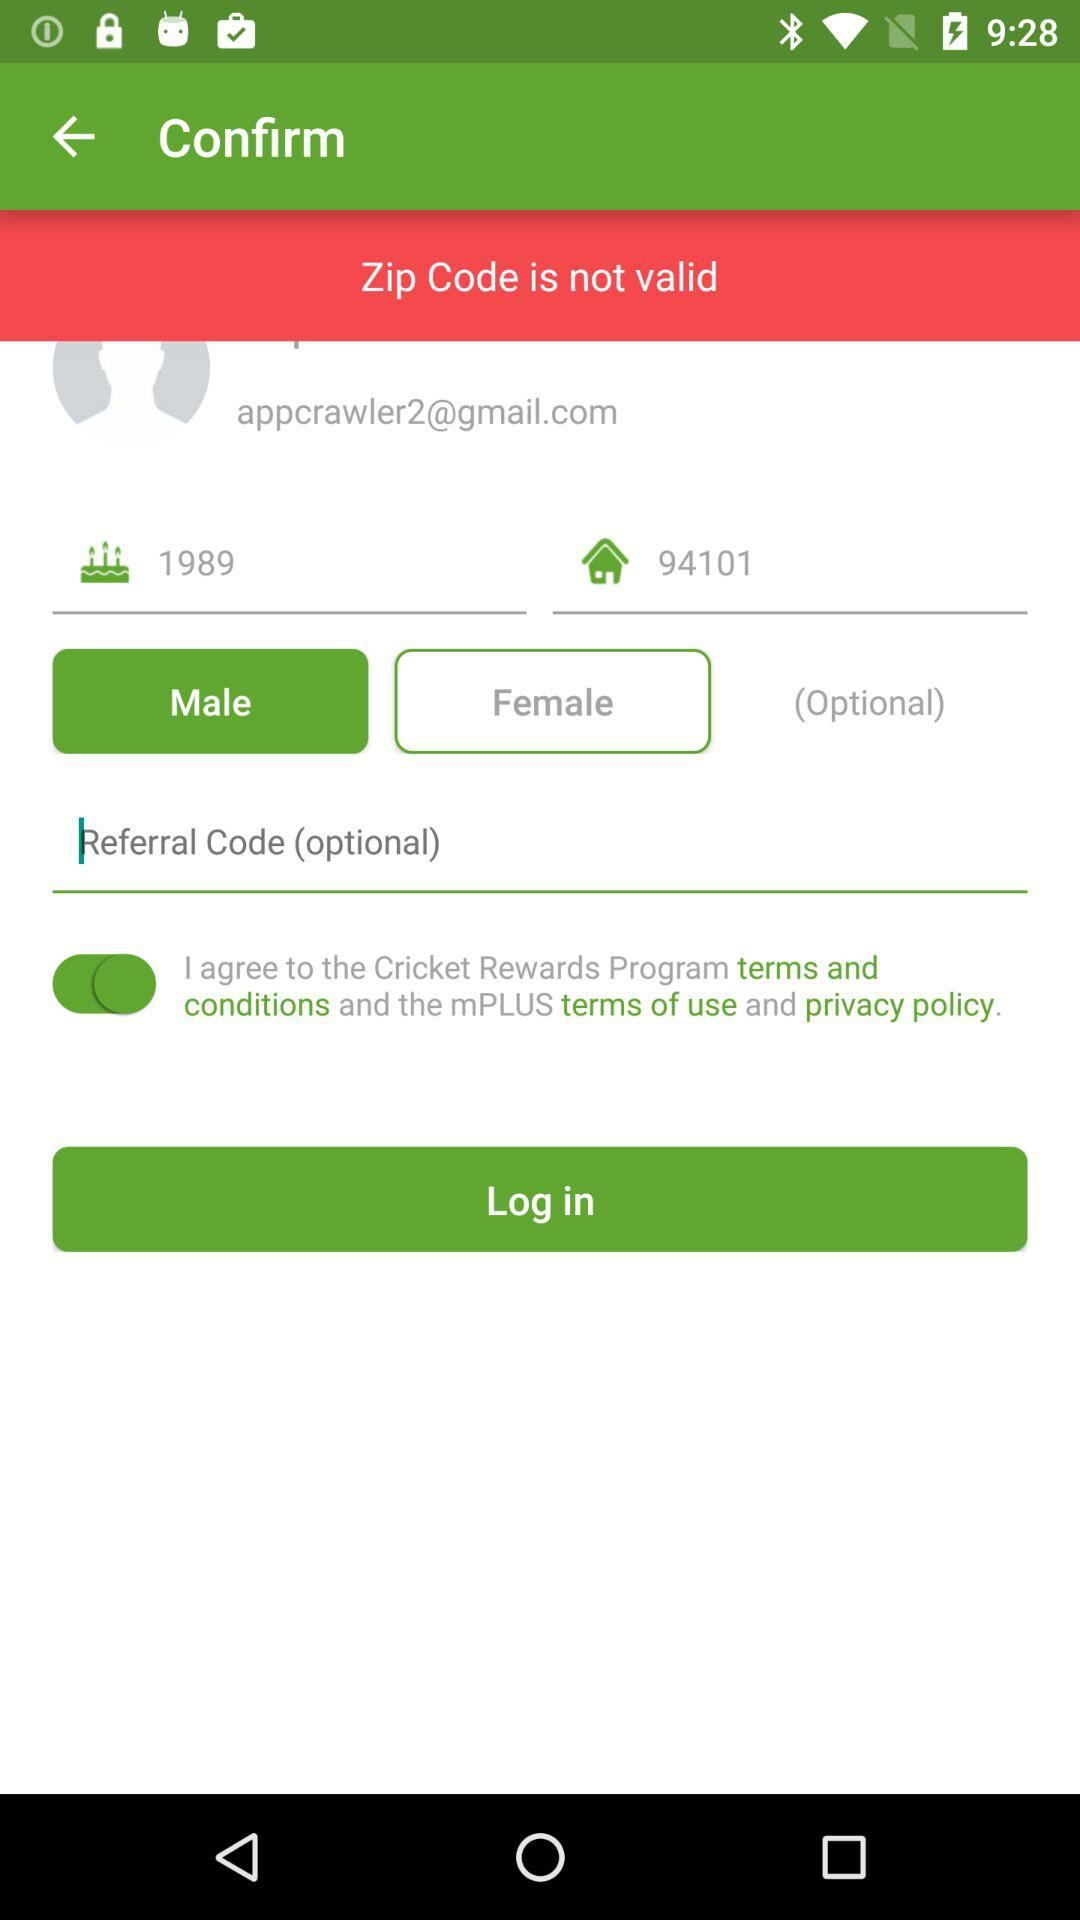What is the email address? The email address is appcrawler2@gmail.com. 